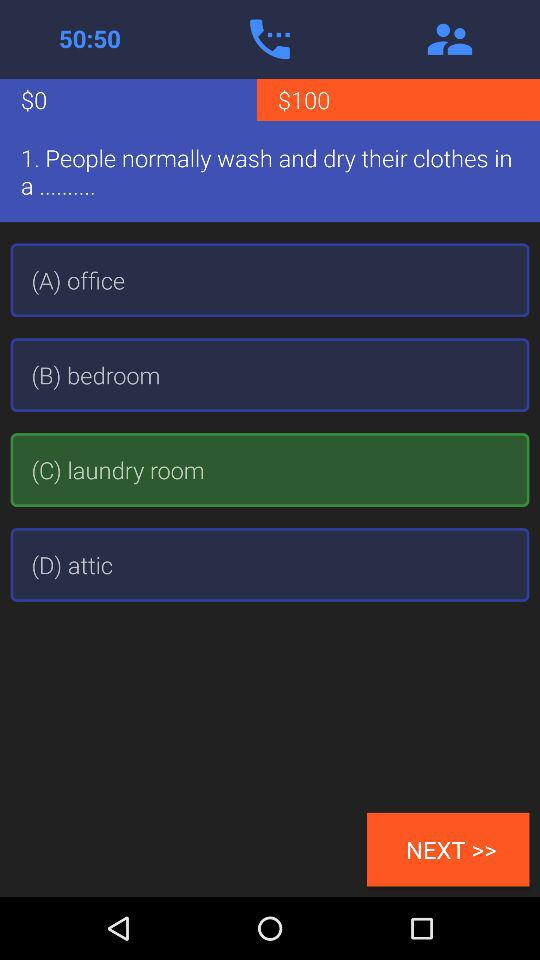What option has been selected? The selected option is "laundry room". 